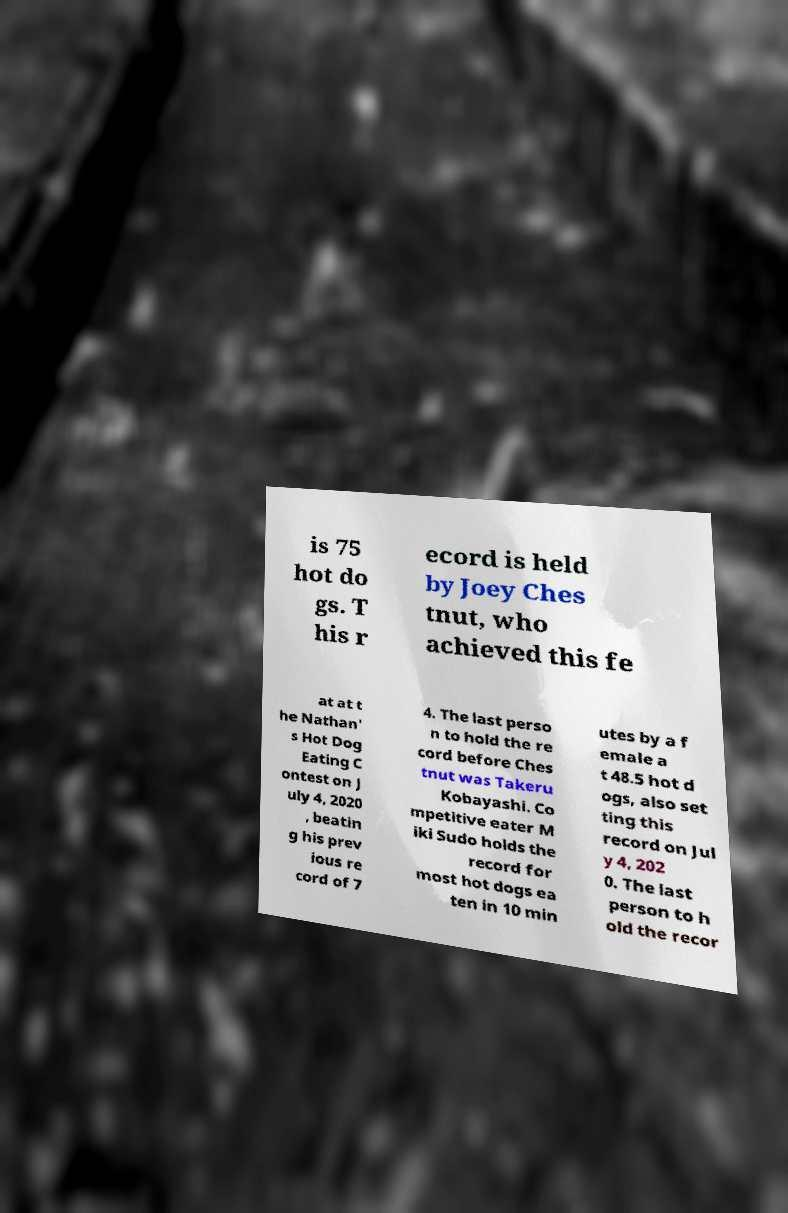Can you accurately transcribe the text from the provided image for me? is 75 hot do gs. T his r ecord is held by Joey Ches tnut, who achieved this fe at at t he Nathan' s Hot Dog Eating C ontest on J uly 4, 2020 , beatin g his prev ious re cord of 7 4. The last perso n to hold the re cord before Ches tnut was Takeru Kobayashi. Co mpetitive eater M iki Sudo holds the record for most hot dogs ea ten in 10 min utes by a f emale a t 48.5 hot d ogs, also set ting this record on Jul y 4, 202 0. The last person to h old the recor 